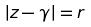<formula> <loc_0><loc_0><loc_500><loc_500>| z - \gamma | = r</formula> 